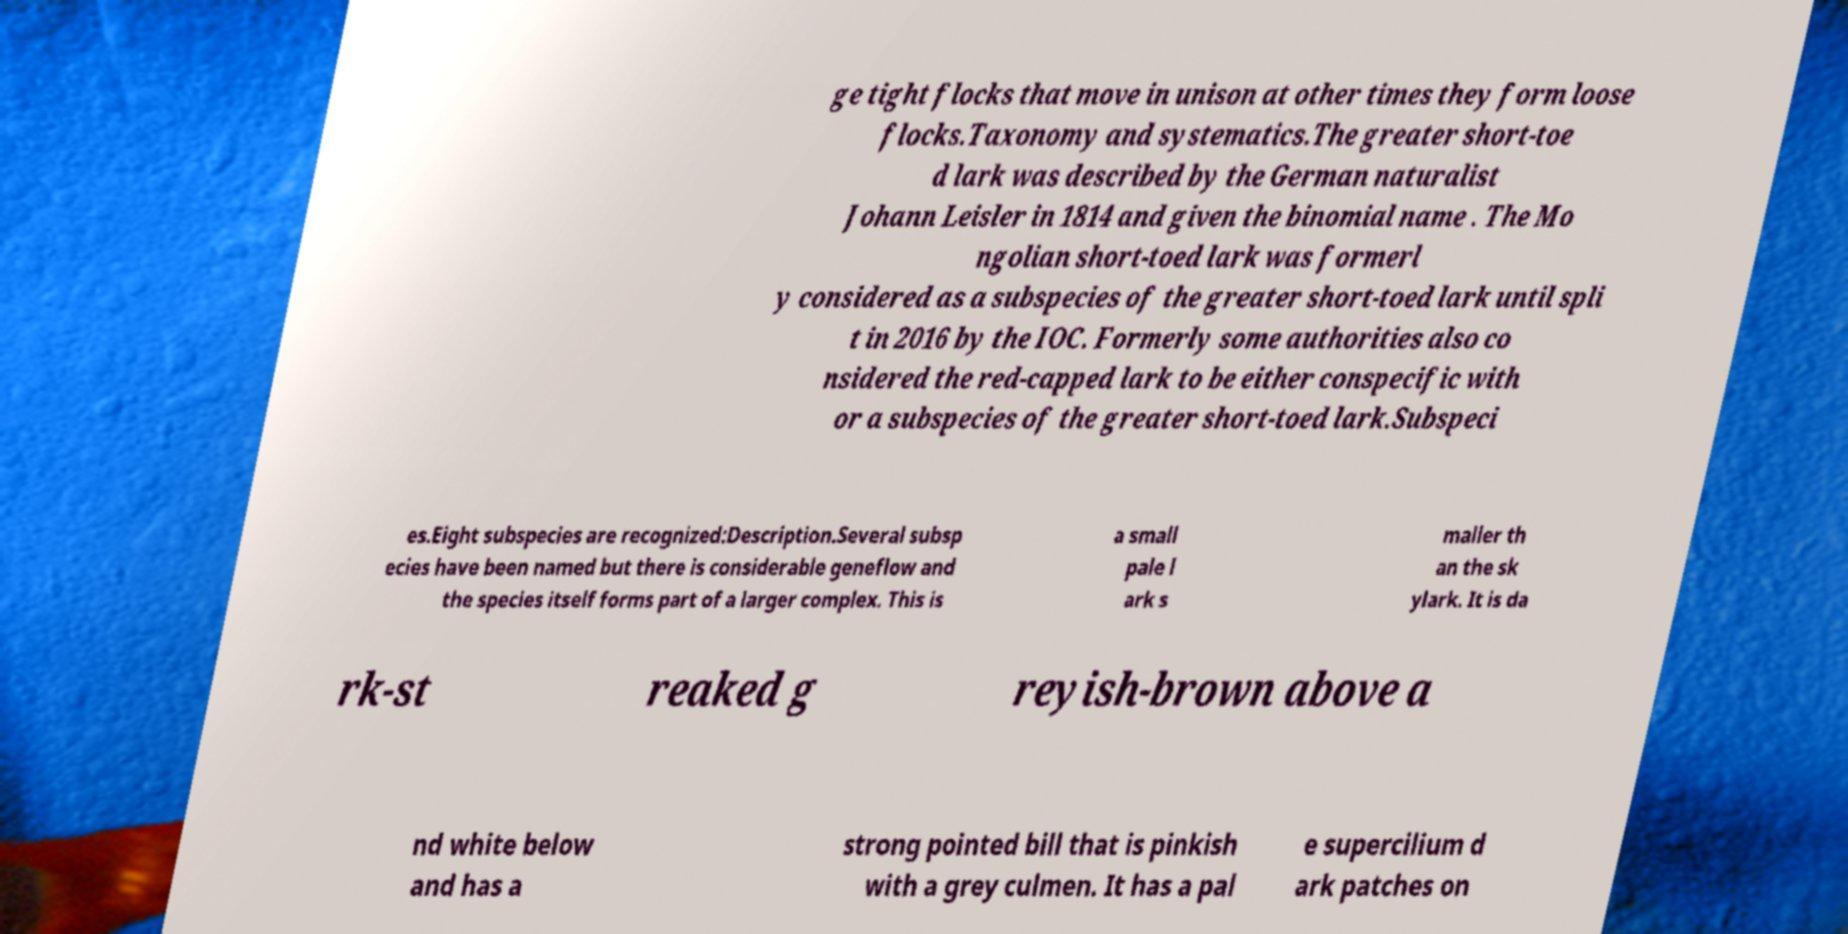Please read and relay the text visible in this image. What does it say? ge tight flocks that move in unison at other times they form loose flocks.Taxonomy and systematics.The greater short-toe d lark was described by the German naturalist Johann Leisler in 1814 and given the binomial name . The Mo ngolian short-toed lark was formerl y considered as a subspecies of the greater short-toed lark until spli t in 2016 by the IOC. Formerly some authorities also co nsidered the red-capped lark to be either conspecific with or a subspecies of the greater short-toed lark.Subspeci es.Eight subspecies are recognized:Description.Several subsp ecies have been named but there is considerable geneflow and the species itself forms part of a larger complex. This is a small pale l ark s maller th an the sk ylark. It is da rk-st reaked g reyish-brown above a nd white below and has a strong pointed bill that is pinkish with a grey culmen. It has a pal e supercilium d ark patches on 